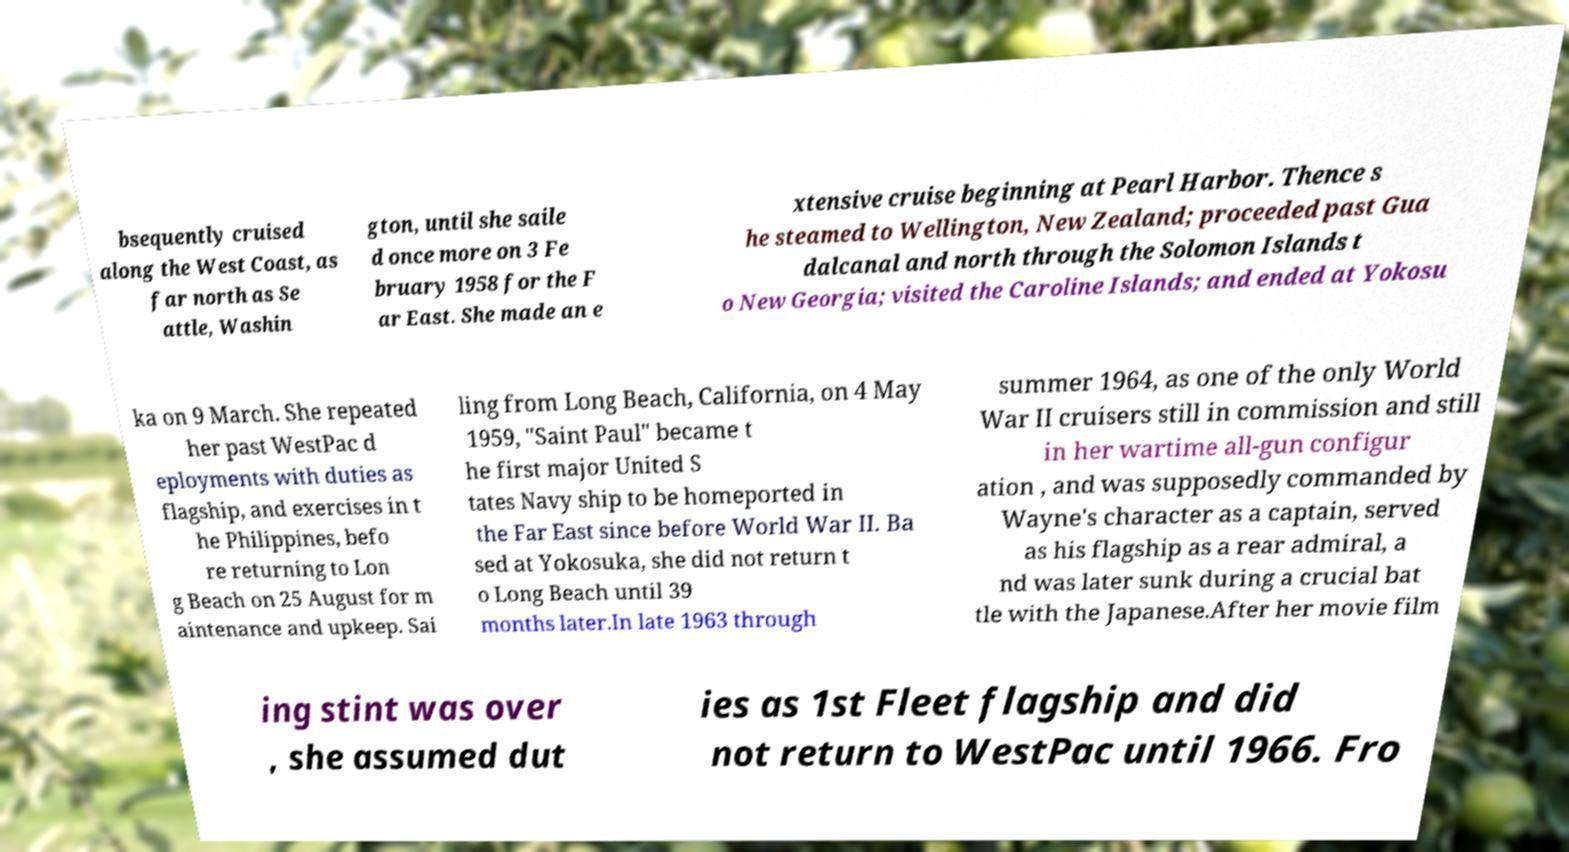Could you extract and type out the text from this image? bsequently cruised along the West Coast, as far north as Se attle, Washin gton, until she saile d once more on 3 Fe bruary 1958 for the F ar East. She made an e xtensive cruise beginning at Pearl Harbor. Thence s he steamed to Wellington, New Zealand; proceeded past Gua dalcanal and north through the Solomon Islands t o New Georgia; visited the Caroline Islands; and ended at Yokosu ka on 9 March. She repeated her past WestPac d eployments with duties as flagship, and exercises in t he Philippines, befo re returning to Lon g Beach on 25 August for m aintenance and upkeep. Sai ling from Long Beach, California, on 4 May 1959, "Saint Paul" became t he first major United S tates Navy ship to be homeported in the Far East since before World War II. Ba sed at Yokosuka, she did not return t o Long Beach until 39 months later.In late 1963 through summer 1964, as one of the only World War II cruisers still in commission and still in her wartime all-gun configur ation , and was supposedly commanded by Wayne's character as a captain, served as his flagship as a rear admiral, a nd was later sunk during a crucial bat tle with the Japanese.After her movie film ing stint was over , she assumed dut ies as 1st Fleet flagship and did not return to WestPac until 1966. Fro 